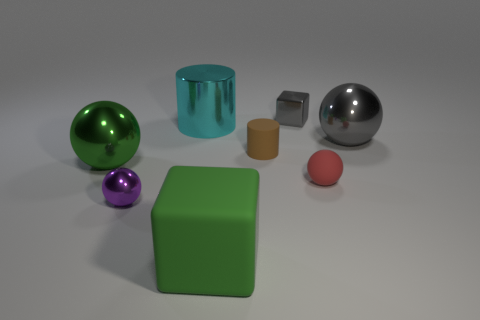Add 2 large cylinders. How many objects exist? 10 Subtract all cubes. How many objects are left? 6 Add 1 big things. How many big things are left? 5 Add 1 small brown spheres. How many small brown spheres exist? 1 Subtract 0 blue cubes. How many objects are left? 8 Subtract all small red matte balls. Subtract all small blue blocks. How many objects are left? 7 